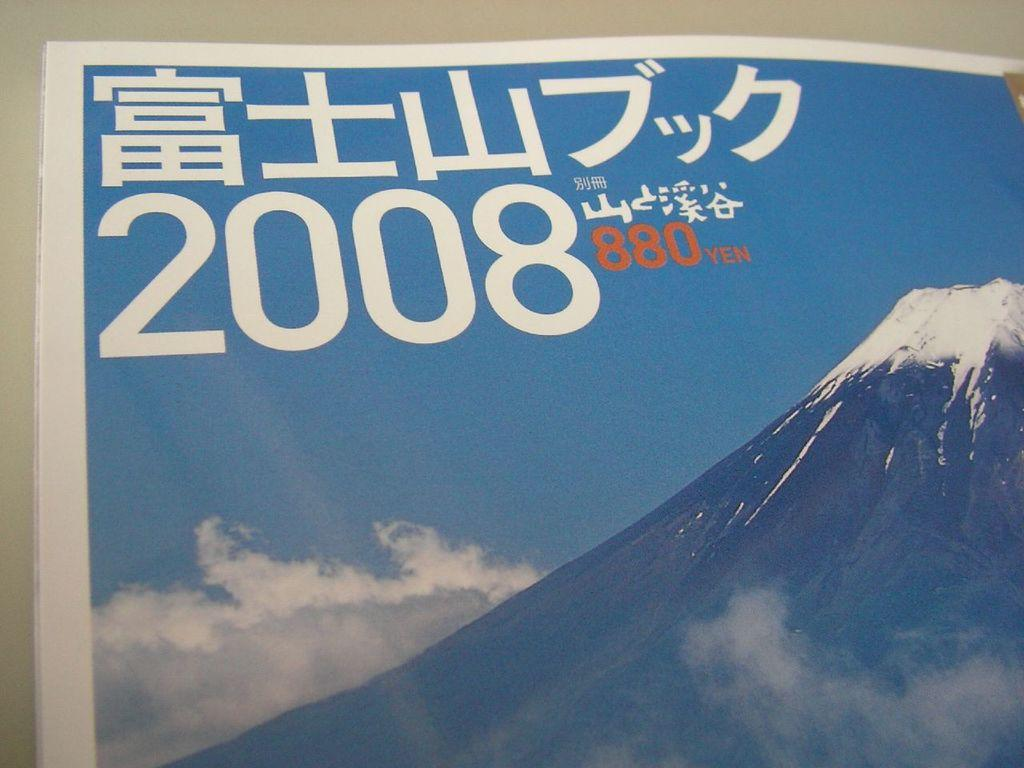Provide a one-sentence caption for the provided image. The foreign language and foreign alphabet calendar is dated 2008 and costs 880 yen. 